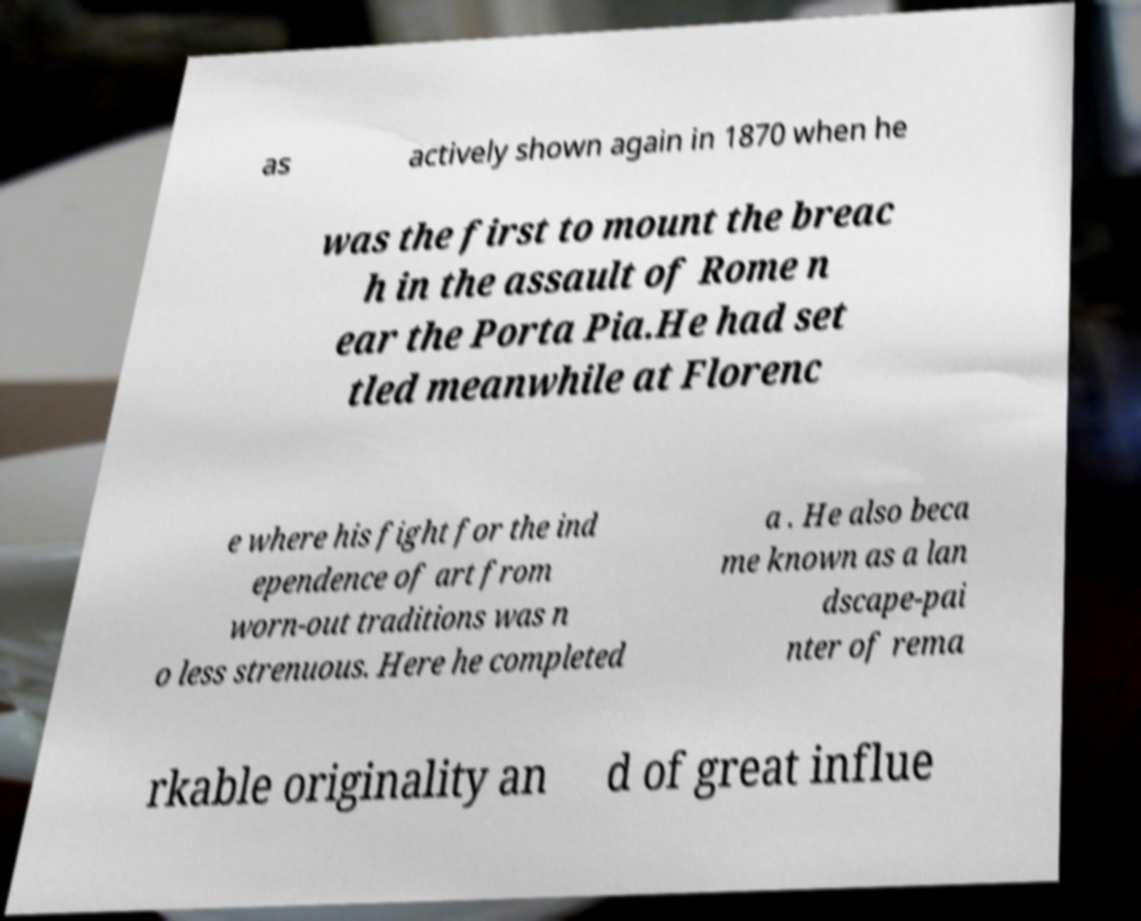There's text embedded in this image that I need extracted. Can you transcribe it verbatim? as actively shown again in 1870 when he was the first to mount the breac h in the assault of Rome n ear the Porta Pia.He had set tled meanwhile at Florenc e where his fight for the ind ependence of art from worn-out traditions was n o less strenuous. Here he completed a . He also beca me known as a lan dscape-pai nter of rema rkable originality an d of great influe 